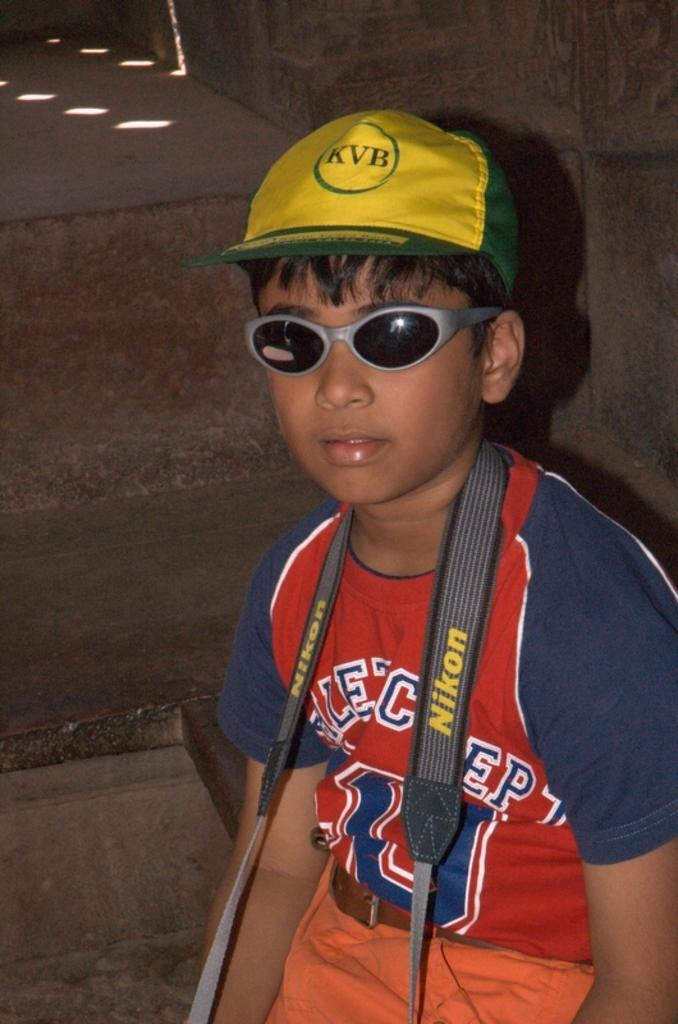Who is the main subject in the image? There is a boy in the image. What is the boy wearing on his face? The boy is wearing spectacles. What type of headwear is the boy wearing? The boy is wearing a hat. What type of substance is the boy holding in his hand in the image? There is no substance visible in the boy's hand in the image. 